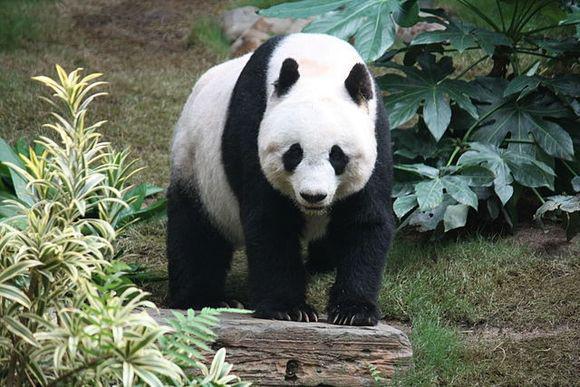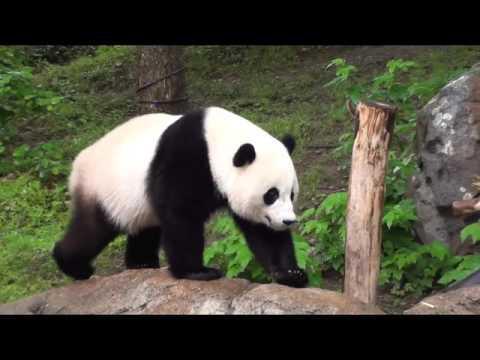The first image is the image on the left, the second image is the image on the right. Considering the images on both sides, is "All pandas are walking on all fours, and at least one panda is walking rightward with the camera-facing front paw forward." valid? Answer yes or no. No. The first image is the image on the left, the second image is the image on the right. Considering the images on both sides, is "In at least one image therei sa panda with a single black stripe on it's back walking in grass white facing forward right." valid? Answer yes or no. No. 